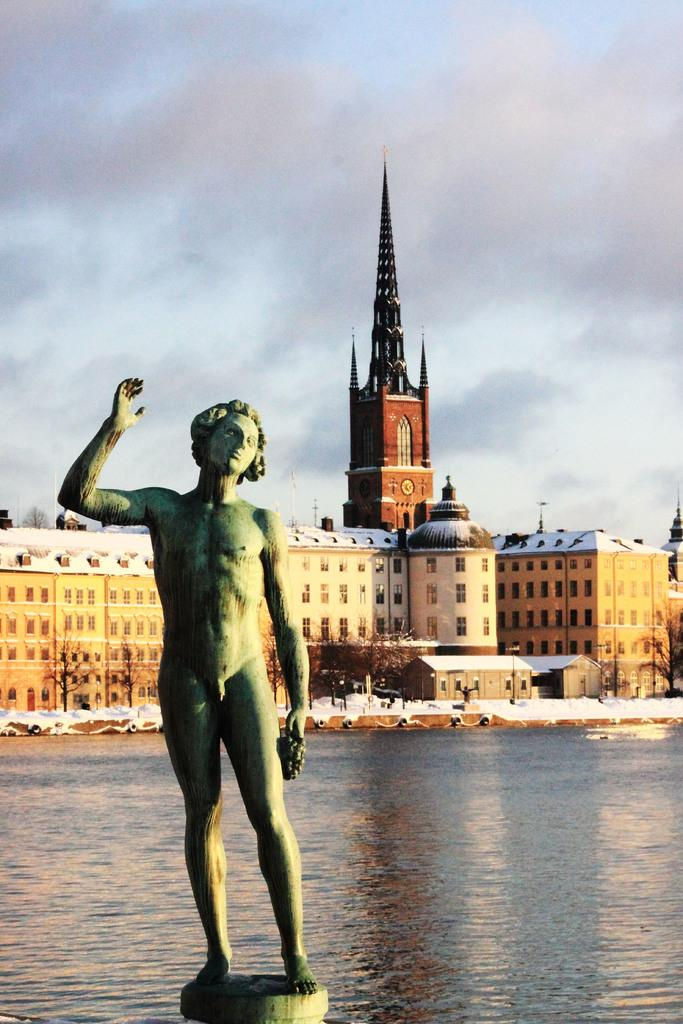What is the main subject of the image? There is a statue of a person in the image. What can be seen in the foreground of the image? Water is visible in the image. What structures can be seen in the background of the image? There is a building and a tower in the background of the image. What is visible in the sky in the image? The sky is visible in the background of the image, and clouds are present. What type of oatmeal is being served at the governor's event in the image? There is no governor or oatmeal present in the image; it features a statue of a person and water in the foreground. What is the statue's nose made of in the image? The provided facts do not mention the statue's nose or its material, so we cannot answer that question definitively. 